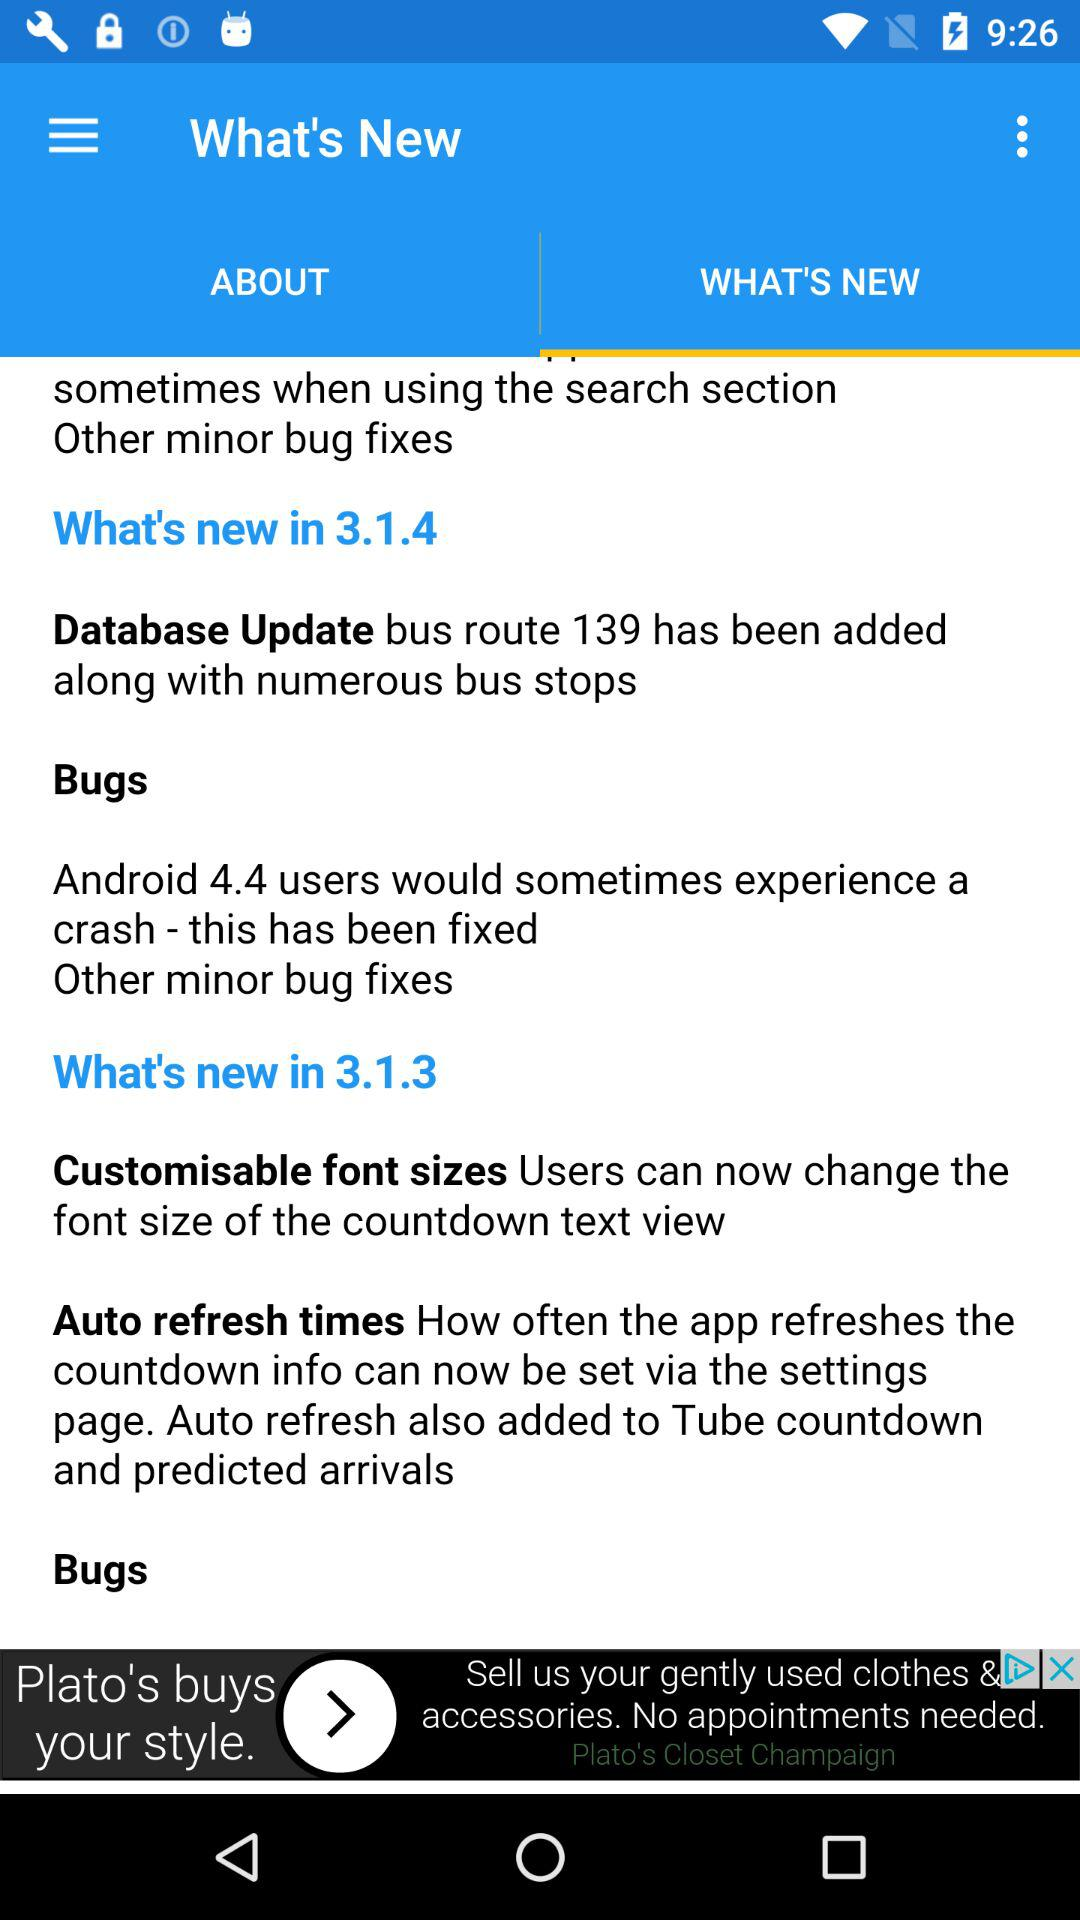Which tab is selected? The selected tab is "WHAT'S NEW". 